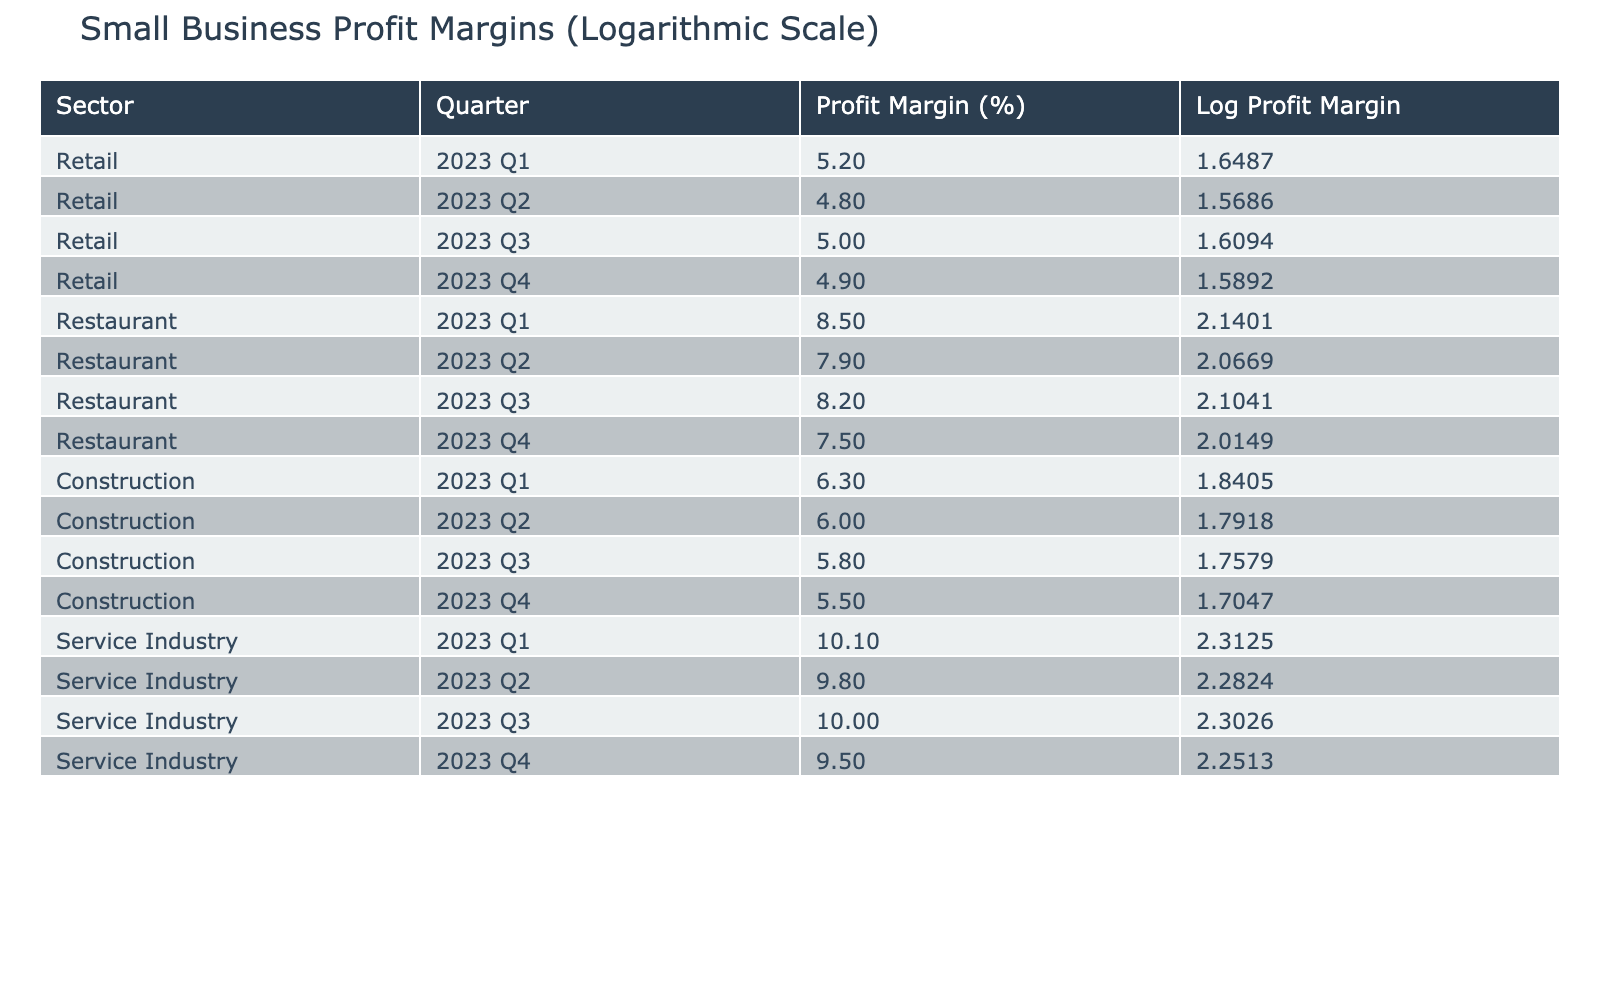What was the profit margin for the Retail sector in 2023 Q1? From the table, we can look under the Retail sector for 2023 Q1, which lists a profit margin of 5.2%.
Answer: 5.2% Which sector had the highest profit margin in 2023 Q4? In 2023 Q4, we examine the profit margins for all sectors. The Service Industry had a profit margin of 9.5%, which is higher than the other sectors listed.
Answer: Service Industry What is the average profit margin for the Restaurant sector over the four quarters? To find the average, we add the profit margins for all Restaurant quarters: (8.5 + 7.9 + 8.2 + 7.5) = 32.1. Then, we divide by 4 for the average, which is 32.1 / 4 = 8.025.
Answer: 8.03 Did the profit margin in the Retail sector decrease from 2023 Q1 to 2023 Q2? By comparing the profit margins in the Retail sector, Q1 had 5.2% and Q2 had 4.8%, indicating a decrease.
Answer: Yes What was the difference in profit margin between 2023 Q3 and 2023 Q4 for the Service Industry? For the Service Industry, Q3 had a profit margin of 10.0%, while Q4 had 9.5%. Thus, the difference is 10.0 - 9.5 = 0.5%.
Answer: 0.5% 